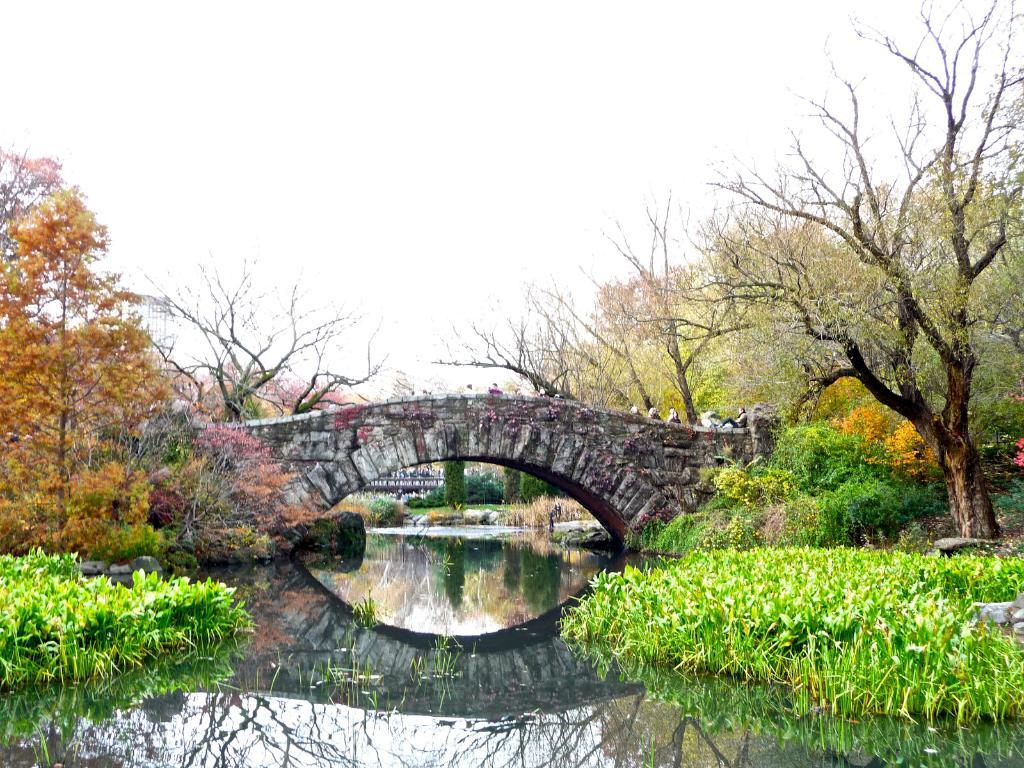What type of vegetation can be seen in the image? There are trees in the image. What structure is present in the image? There is a bridge in the image. What natural element is visible in the image? There is water visible in the image. What is present in the water? There are plants in the water. What are the people in the image doing? There are people standing on the bridge. What other structure can be seen in the background? There is another bridge visible in the background. How would you describe the weather in the image? The sky is cloudy in the image. What type of business is being conducted on the bridge in the image? There is no indication of any business being conducted in the image; it simply shows people standing on a bridge. Can you see any family members interacting with each other in the image? There is no information about family members or their interactions in the image. 